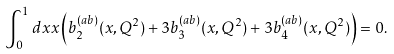<formula> <loc_0><loc_0><loc_500><loc_500>\int _ { 0 } ^ { 1 } d x x \left ( b _ { 2 } ^ { ( a b ) } ( x , Q ^ { 2 } ) + 3 b _ { 3 } ^ { ( a b ) } ( x , Q ^ { 2 } ) + 3 b _ { 4 } ^ { ( a b ) } ( x , Q ^ { 2 } ) \right ) = 0 .</formula> 